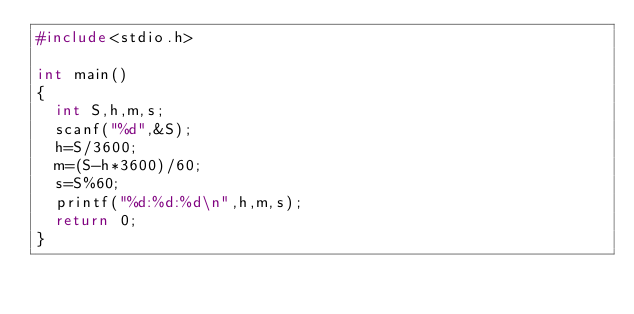<code> <loc_0><loc_0><loc_500><loc_500><_C_>#include<stdio.h>

int main()
{
  int S,h,m,s;
  scanf("%d",&S);
  h=S/3600;
  m=(S-h*3600)/60;
  s=S%60;
  printf("%d:%d:%d\n",h,m,s);
  return 0;
}</code> 